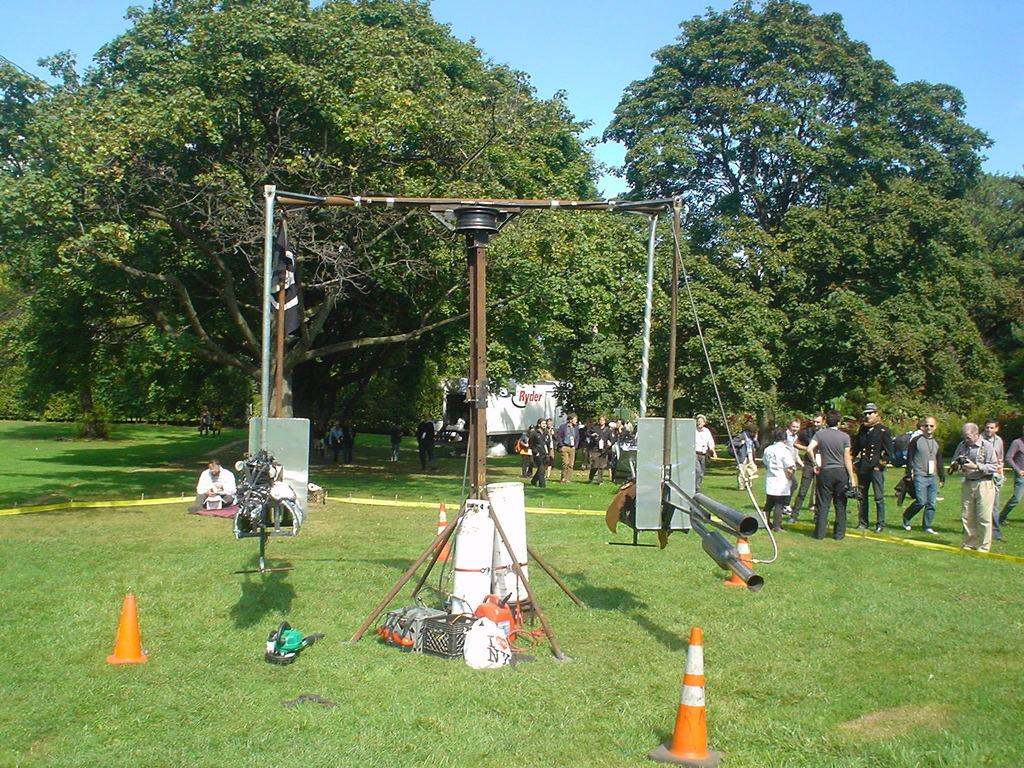What objects are present in the image that are used to control traffic? There are traffic cones in the image. What other subjects can be seen in the image? There are people, trees, a building, and grass visible in the image. What is visible at the top of the image? The sky is visible at the top of the image. What type of glass is being used to create the light in the image? There is no glass or light present in the image; it features traffic cones, people, trees, a building, grass, and the sky. What is the cause of the traffic cones in the image? The cause of the traffic cones in the image is not mentioned or visible, but they are likely used for traffic control or construction purposes. 